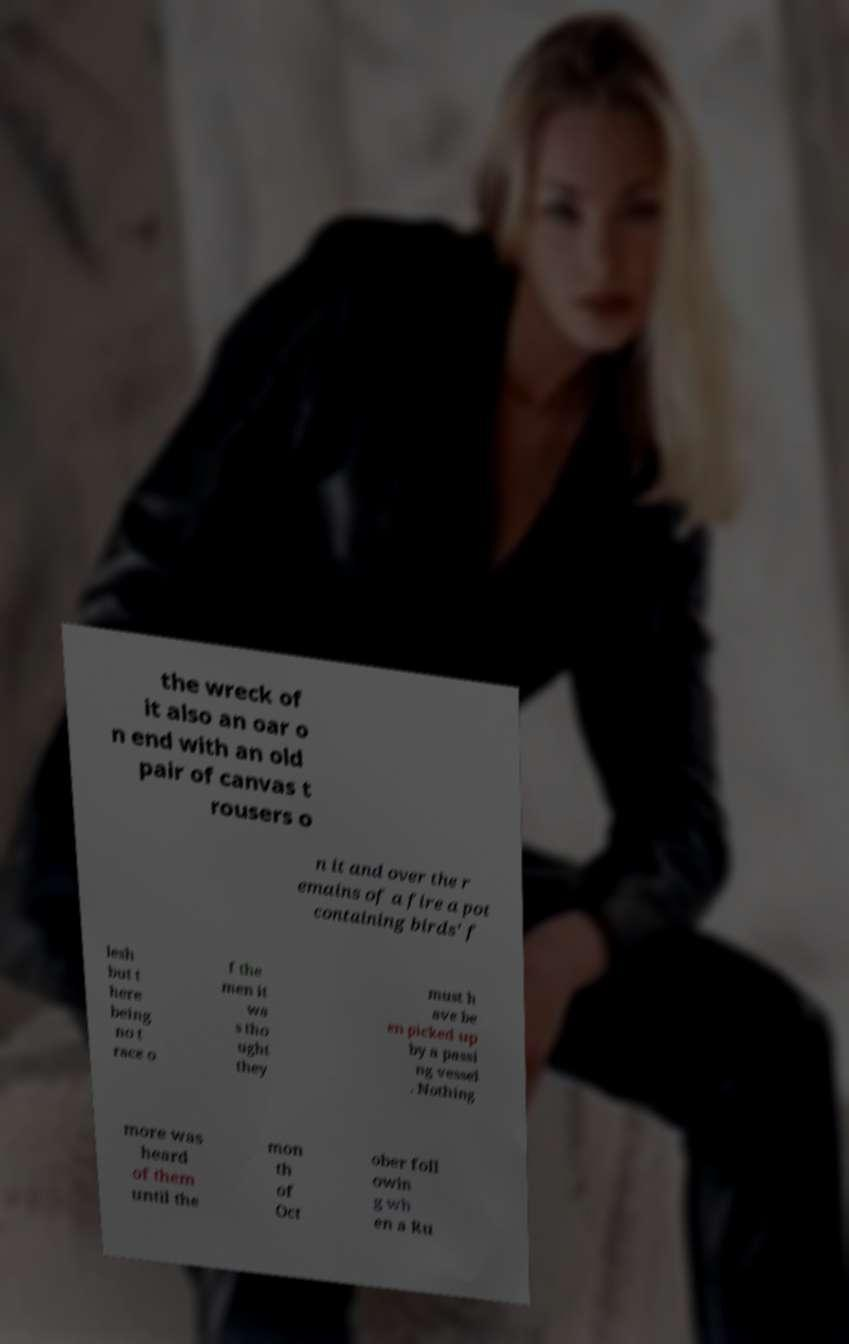What messages or text are displayed in this image? I need them in a readable, typed format. the wreck of it also an oar o n end with an old pair of canvas t rousers o n it and over the r emains of a fire a pot containing birds' f lesh but t here being no t race o f the men it wa s tho ught they must h ave be en picked up by a passi ng vessel . Nothing more was heard of them until the mon th of Oct ober foll owin g wh en a Ru 